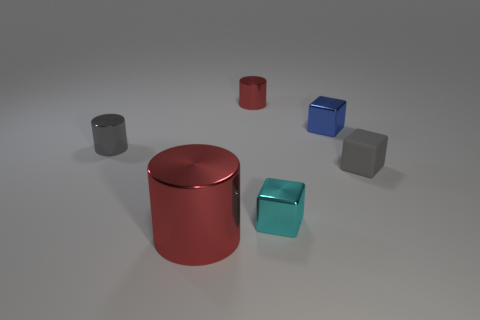What shape is the other matte thing that is the same size as the blue object?
Provide a short and direct response. Cube. There is a cylinder in front of the gray shiny object; what number of metal objects are in front of it?
Your response must be concise. 0. Are there more small gray blocks than green shiny spheres?
Give a very brief answer. Yes. Do the large red cylinder and the gray cylinder have the same material?
Provide a short and direct response. Yes. Is the number of tiny cyan metallic blocks behind the blue shiny block the same as the number of tiny green things?
Ensure brevity in your answer.  Yes. What number of cylinders are made of the same material as the small red object?
Provide a succinct answer. 2. Are there fewer red metallic objects than small green balls?
Give a very brief answer. No. There is a tiny metal cylinder in front of the small red cylinder; is its color the same as the matte thing?
Offer a very short reply. Yes. There is a small shiny cylinder that is left of the tiny object behind the blue metal block; what number of small cyan metal things are left of it?
Your answer should be very brief. 0. There is a cyan block; what number of big red metallic objects are behind it?
Ensure brevity in your answer.  0. 